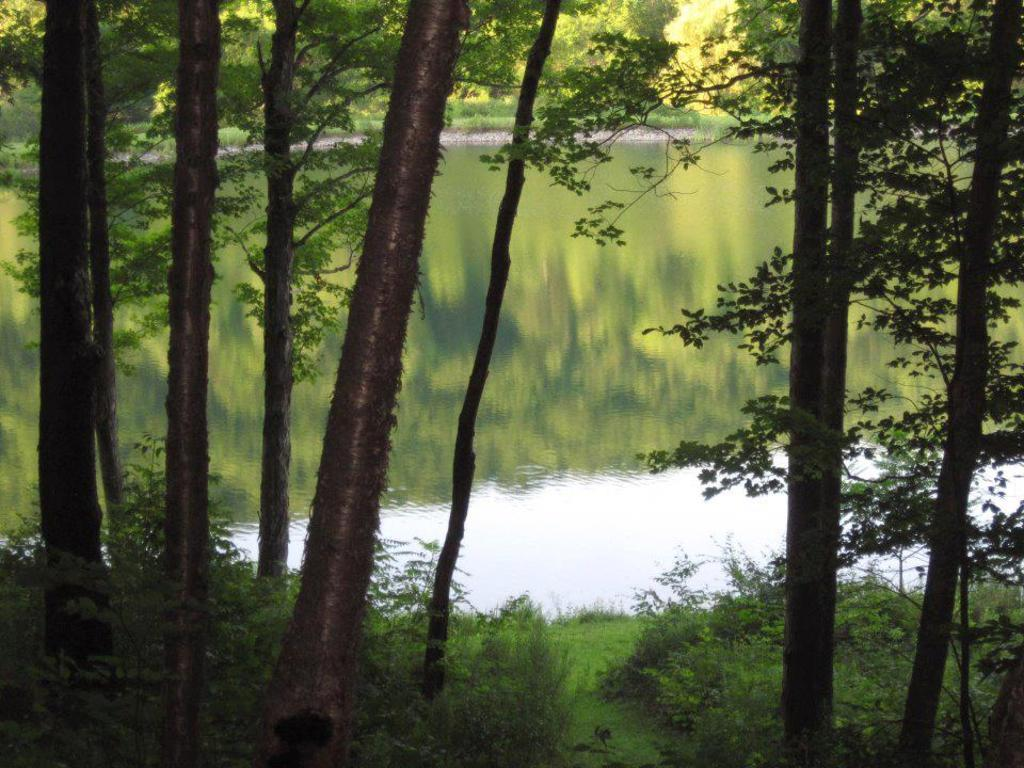What type of vegetation can be seen in the image? There are trees, plants, and grass visible in the image. Can you describe the natural environment in the image? The natural environment includes trees, plants, grass, and water visible in the background. How many apples are hanging from the trees in the image? There are no apples visible in the image; only trees, plants, and grass can be seen. What type of utensil is being used by the partner in the image? There is no partner or utensil present in the image. 